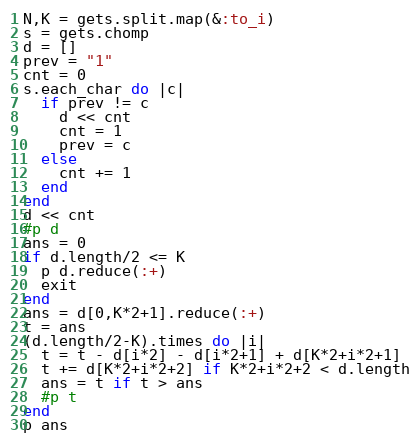<code> <loc_0><loc_0><loc_500><loc_500><_Ruby_>N,K = gets.split.map(&:to_i)
s = gets.chomp
d = []
prev = "1"
cnt = 0
s.each_char do |c|
  if prev != c
    d << cnt
    cnt = 1
    prev = c
  else
    cnt += 1
  end
end
d << cnt
#p d
ans = 0
if d.length/2 <= K
  p d.reduce(:+)
  exit
end
ans = d[0,K*2+1].reduce(:+)
t = ans
(d.length/2-K).times do |i|
  t = t - d[i*2] - d[i*2+1] + d[K*2+i*2+1]
  t += d[K*2+i*2+2] if K*2+i*2+2 < d.length
  ans = t if t > ans
  #p t
end
p ans
</code> 